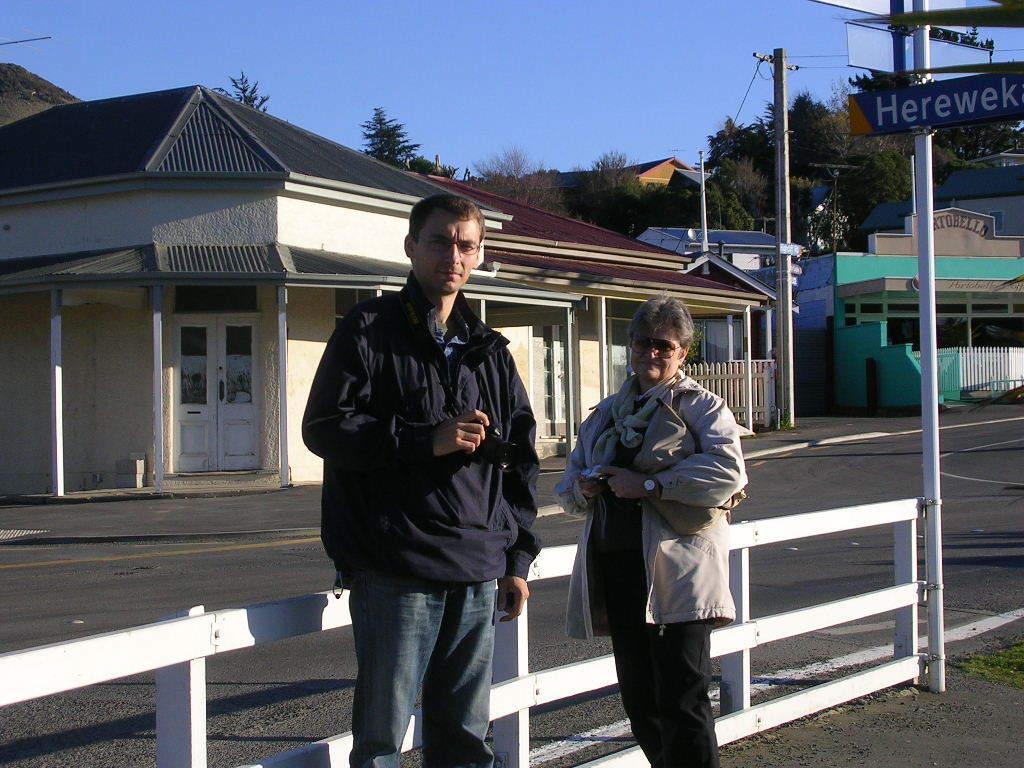How would you summarize this image in a sentence or two? We can see black road and white color wooden barefoot. We can see two people standing over there a man with blue color jacket and women with the white jacket. We can see electric poles in this picture. On the left side, we can see a house with grey and brown color rooftop. On the backside we can see mountains and trees. 